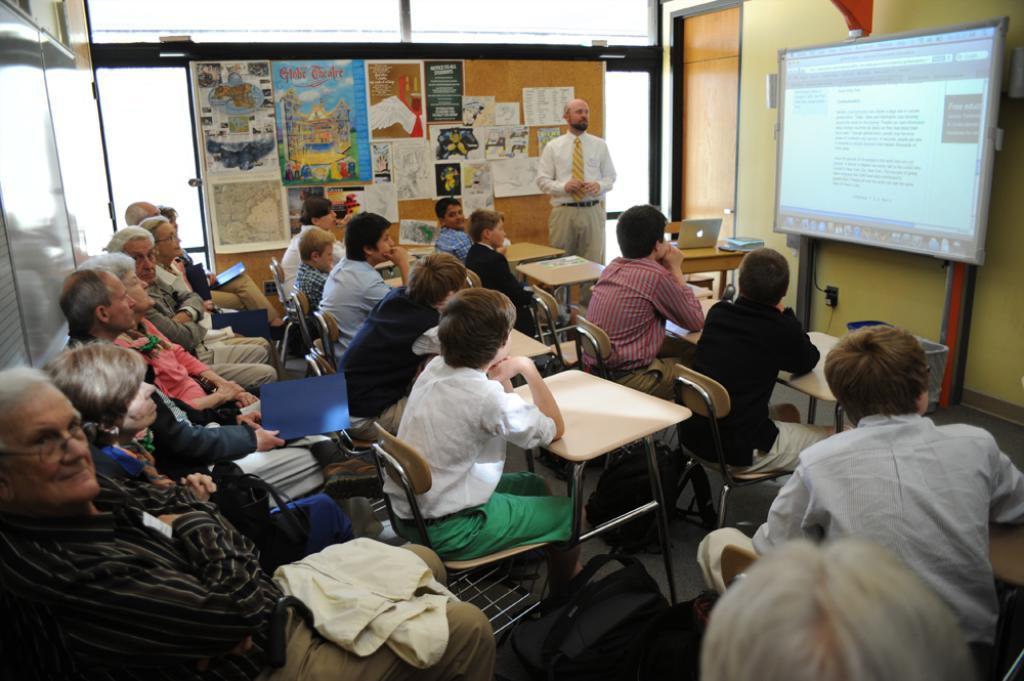Could you give a brief overview of what you see in this image? In this picture there are a group of people sitting and looking at the screen. There is a person standing here and there is a laptop here and there are many posters pasted on the wall 